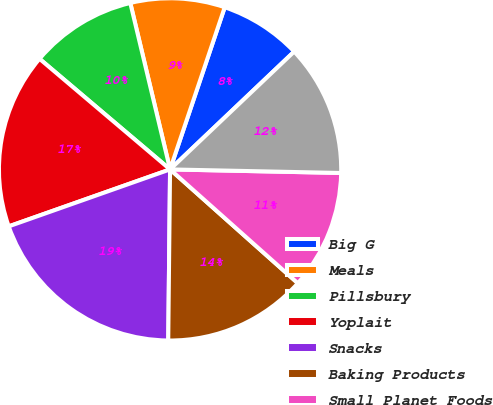Convert chart to OTSL. <chart><loc_0><loc_0><loc_500><loc_500><pie_chart><fcel>Big G<fcel>Meals<fcel>Pillsbury<fcel>Yoplait<fcel>Snacks<fcel>Baking Products<fcel>Small Planet Foods<fcel>Total<nl><fcel>7.74%<fcel>8.91%<fcel>10.08%<fcel>16.59%<fcel>19.43%<fcel>13.59%<fcel>11.25%<fcel>12.42%<nl></chart> 